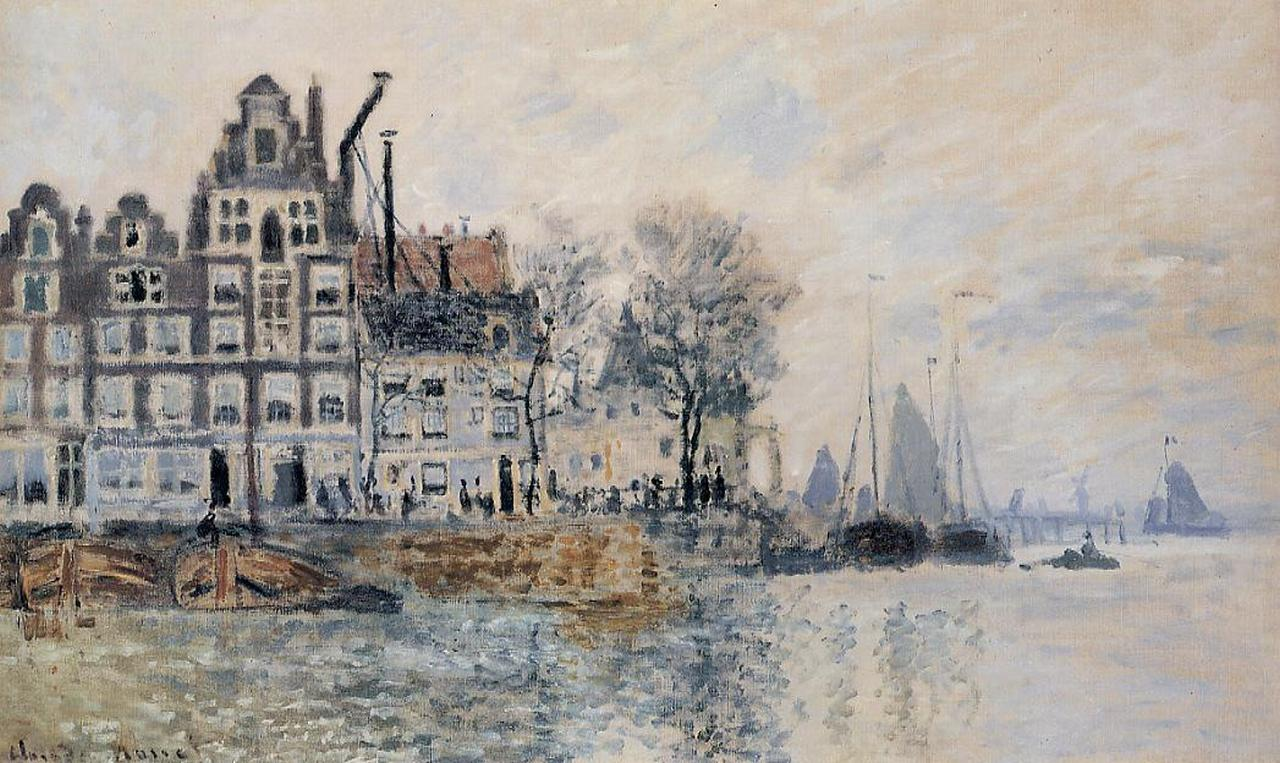What time of day do you think it is in this image? The image seems to depict a late afternoon or early evening scene. The muted lighting and subtle shadows suggest that the sun is low on the horizon, possibly obscured by clouds, creating a calm and serene atmosphere. The soft, diffused light illuminates the buildings and river gently, contributing to the tranquil mood of the painting. Do you think it might rain soon in the setting of this image? There’s a possibility that it could rain soon. The overcast sky, filled with soft clouds, suggests that the weather might be unpredictable. The overall damp, cool tones used in the painting hint at a mood that could precede a gentle rain shower. The atmosphere feels calm yet expectant, adding a layer of quiet anticipation to the scene. 